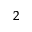<formula> <loc_0><loc_0><loc_500><loc_500>^ { 2 }</formula> 